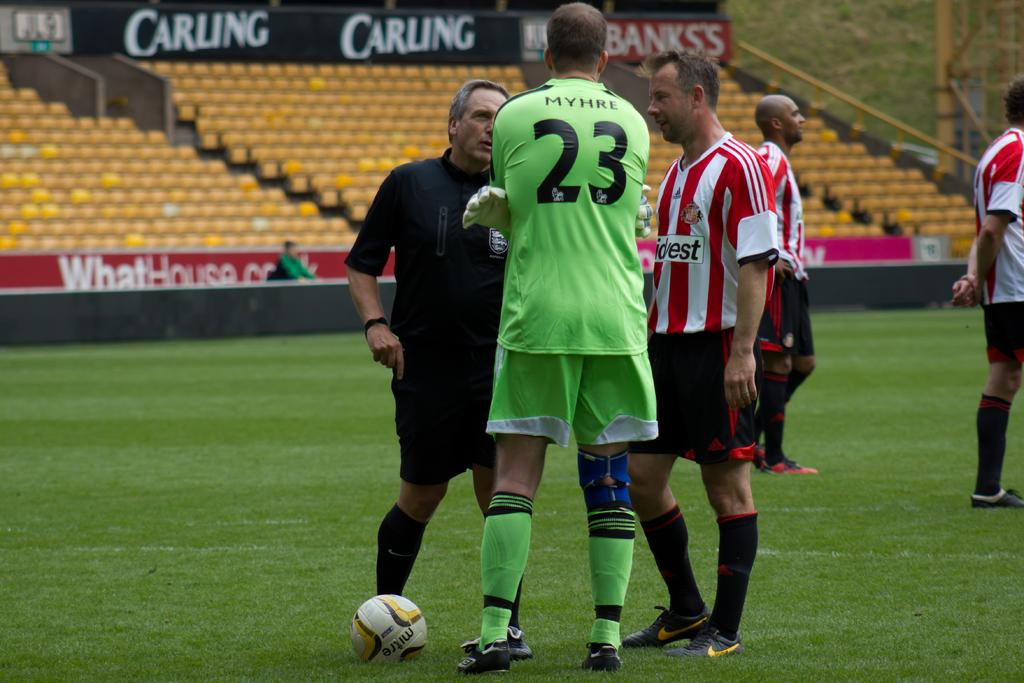<image>
Write a terse but informative summary of the picture. Rugby player Myhre, number 23, is talking to two men on the field. 